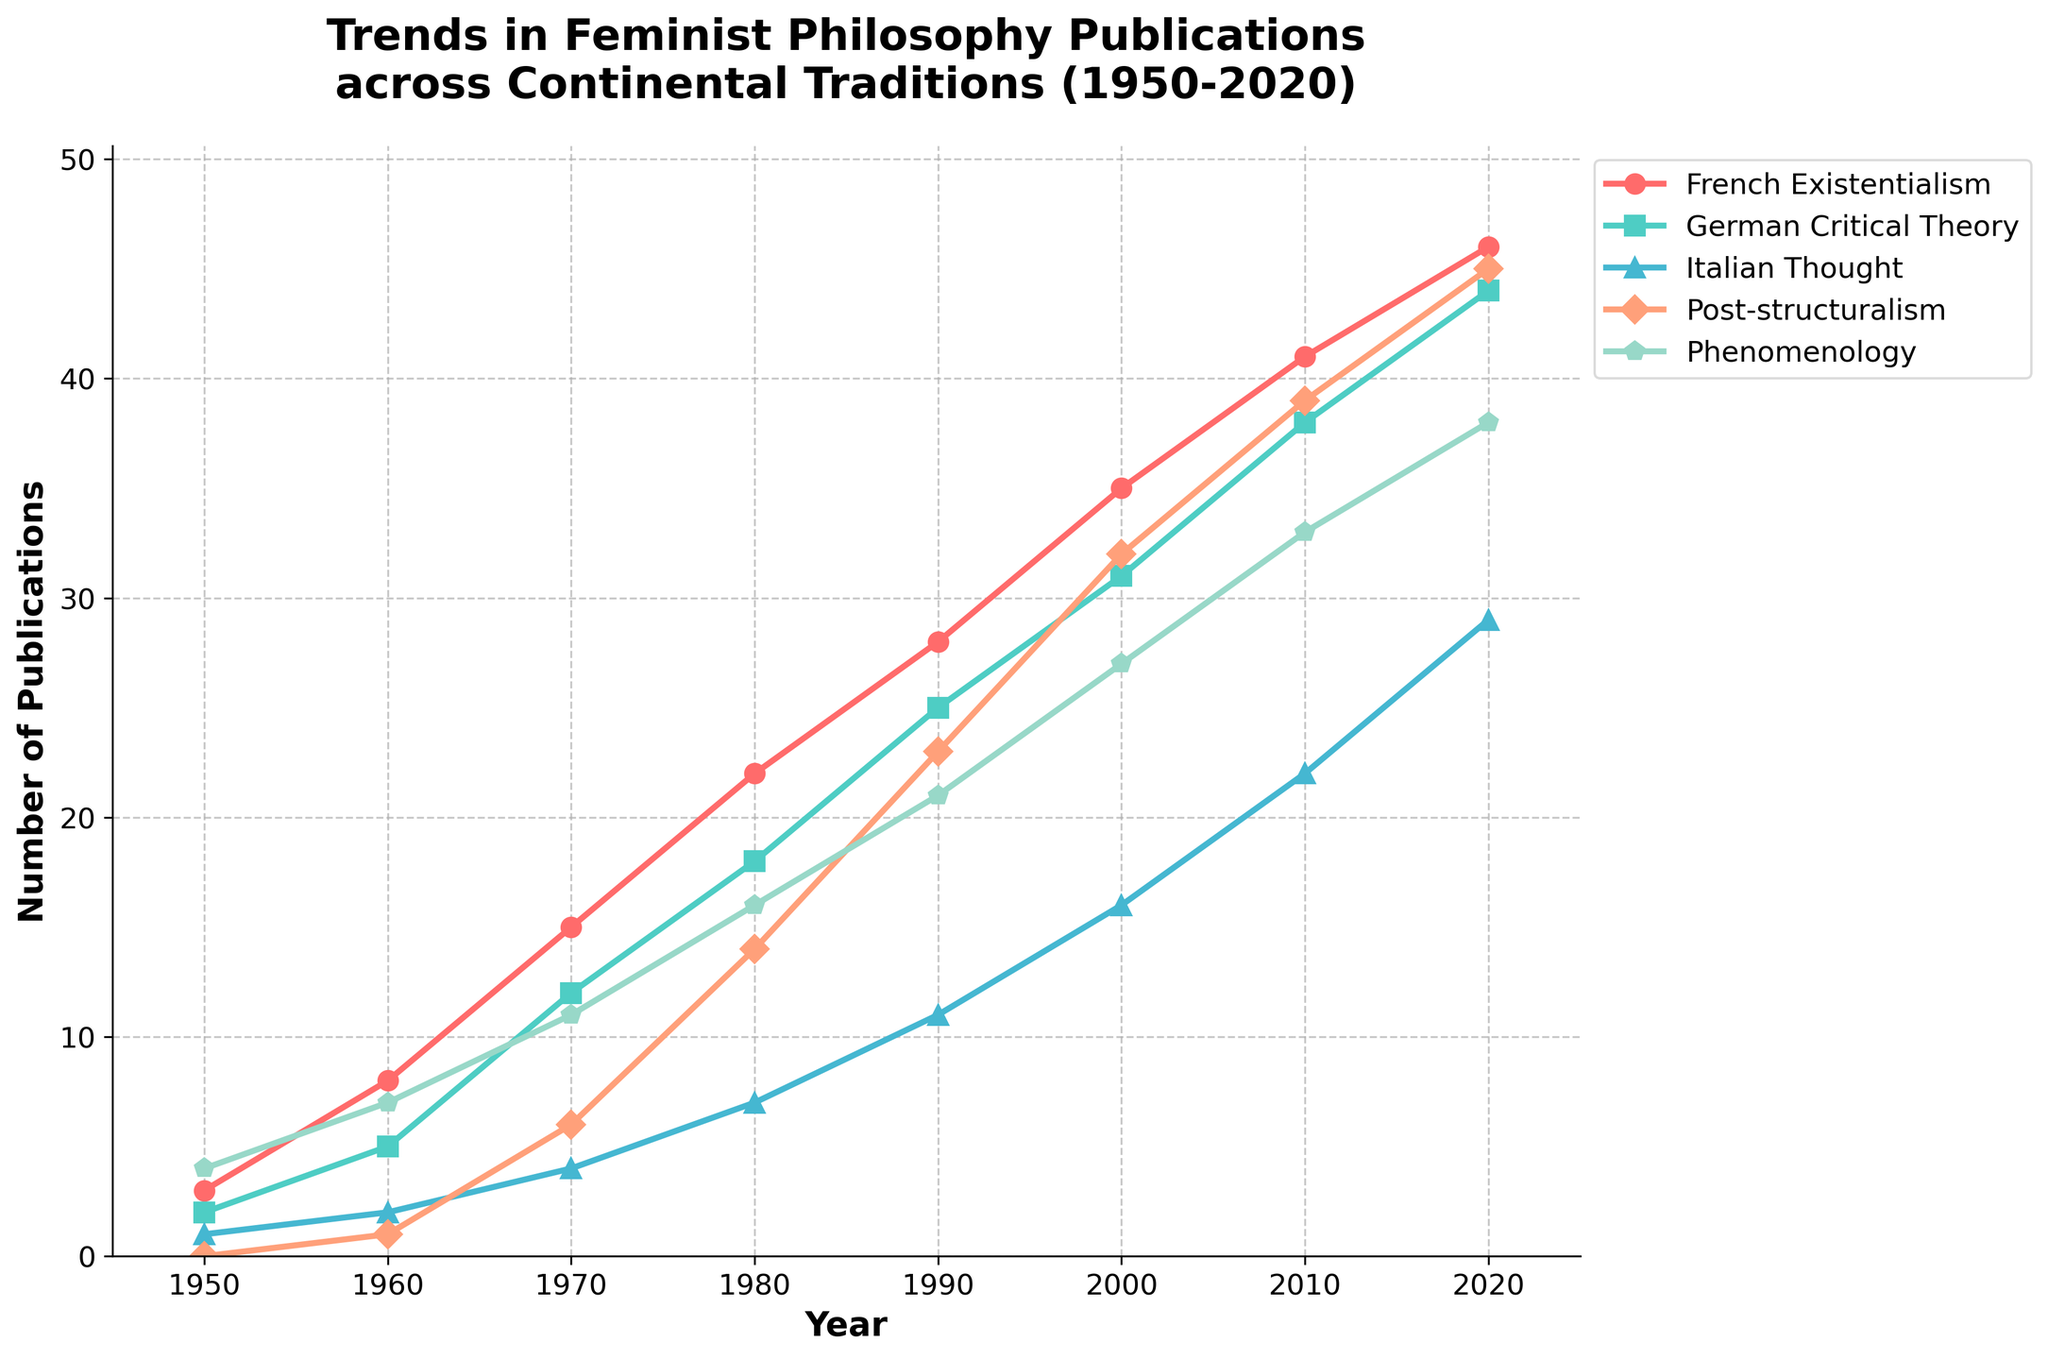What is the trend in publications related to French Existentialism from 1950 to 2020? To find the trend, observe the line representing French Existentialism. The publications rise consistently from 3 in 1950 to 46 in 2020, indicating an upward trend throughout the years.
Answer: Upward Compare the number of publications in German Critical Theory and Post-structuralism in 1980. Which has more? Look at the points on the lines for German Critical Theory and Post-structuralism in 1980. German Critical Theory has 18 publications, while Post-structuralism has 14.
Answer: German Critical Theory Between which two consecutive decades did Italian Thought publications experience the highest increase? Calculate the publication differences between consecutive decades: 1950-1960 (2-1=1), 1960-1970 (4-2=2), 1970-1980 (7-4=3), 1980-1990 (11-7=4), 1990-2000 (16-11=5), 2000-2010 (22-16=6), 2010-2020 (29-22=7). The highest increase is between 2010-2020 with an increase of 7.
Answer: 2010 to 2020 Which tradition had the highest number of publications in 1990? Find the highest point in 1990 among all lines. Phenomenology had 21 publications, which is the highest among all traditions in that year.
Answer: Phenomenology What is the average number of publications for Phenomenology across all decades? Add the publications in each decade for Phenomenology (4+7+11+16+21+27+33+38=157) and divide by the number of decades (8). The average is 157/8 = 19.625.
Answer: 19.625 How does the trend in Post-structuralism compare to that of French Existentialism from 1950 to 2020? Observe both trends over the years. Both show an upward trend, but Post-structuralism starts later (at 0 in 1950) and increases more slowly than French Existentialism.
Answer: Similar trend but slower for Post-structuralism What is the difference in the number of publications between French Existentialism and Italian Thought in 2020? Find the values for both traditions in 2020: French Existentialism (46) and Italian Thought (29). The difference is 46 - 29 = 17.
Answer: 17 Which tradition shows the most steady growth from 1950 to 2020? Compare the consistency of growth across all traditions by examining the smoothness of the lines. French Existentialism shows a steady and consistent growth pattern without any sudden jumps or drops.
Answer: French Existentialism In what year did Phenomenology publications exceed 20 for the first time? Check the Phenomenology line and find the first year where the publication count exceeds 20. This occurs in 1990.
Answer: 1990 